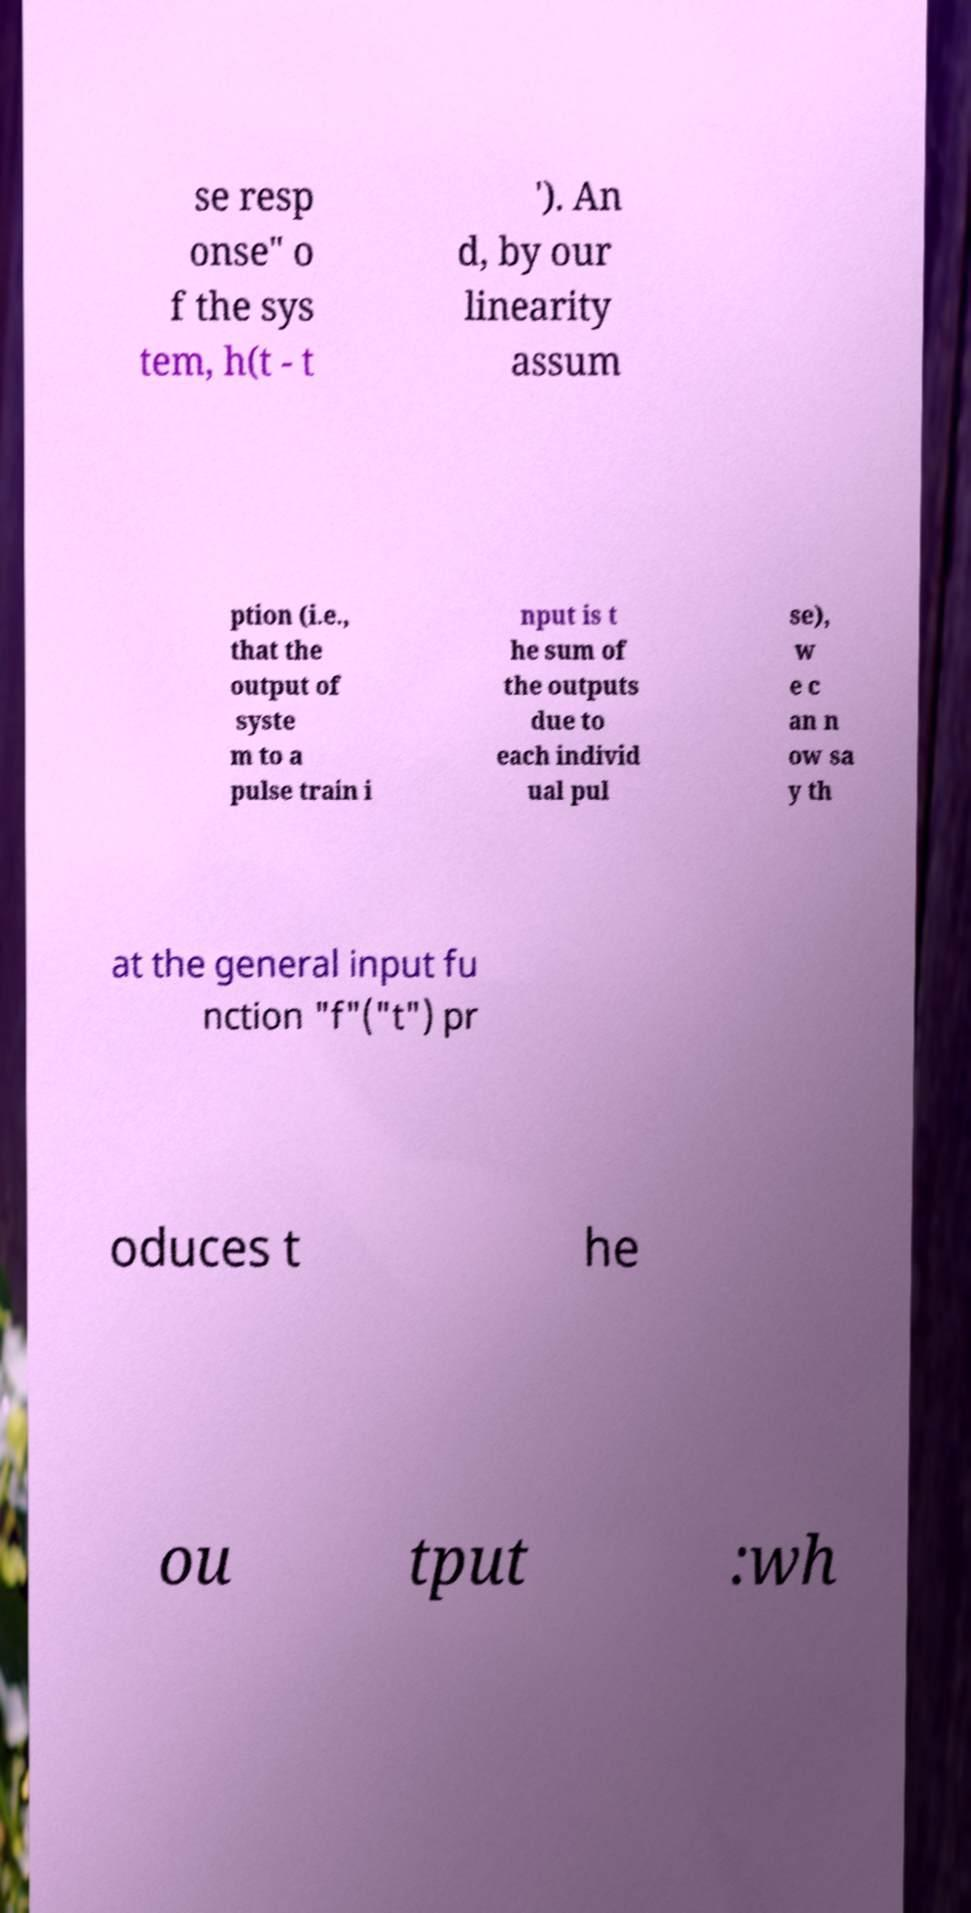Can you read and provide the text displayed in the image?This photo seems to have some interesting text. Can you extract and type it out for me? se resp onse" o f the sys tem, h(t - t '). An d, by our linearity assum ption (i.e., that the output of syste m to a pulse train i nput is t he sum of the outputs due to each individ ual pul se), w e c an n ow sa y th at the general input fu nction "f"("t") pr oduces t he ou tput :wh 